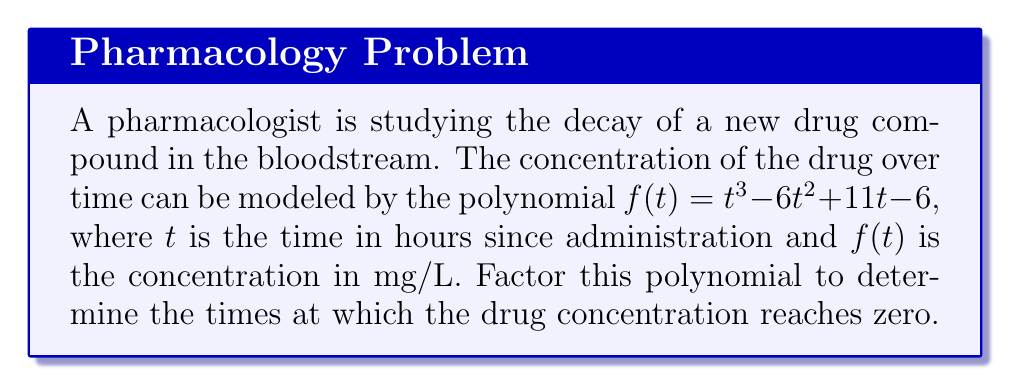Show me your answer to this math problem. To factor this polynomial, we'll follow these steps:

1) First, let's check if there are any rational roots using the rational root theorem. The possible rational roots are the factors of the constant term: $\pm 1, \pm 2, \pm 3, \pm 6$.

2) Testing these values, we find that $f(1) = 0$. So $(t-1)$ is a factor.

3) We can use polynomial long division to divide $f(t)$ by $(t-1)$:

   $t^3 - 6t^2 + 11t - 6 = (t-1)(t^2 - 5t + 6)$

4) Now we need to factor the quadratic term $t^2 - 5t + 6$. We can do this by finding two numbers that multiply to give 6 and add to give -5. These numbers are -2 and -3.

5) Therefore, $t^2 - 5t + 6 = (t-2)(t-3)$

6) Combining all factors, we get:

   $f(t) = (t-1)(t-2)(t-3)$

This factorization tells us that the drug concentration reaches zero at $t = 1$, $t = 2$, and $t = 3$ hours after administration.

From a pharmacological perspective, this suggests that the drug has a complex decay pattern, potentially involving multiple elimination pathways or metabolic processes that lead to complete clearance at these specific time points.
Answer: $f(t) = (t-1)(t-2)(t-3)$ 